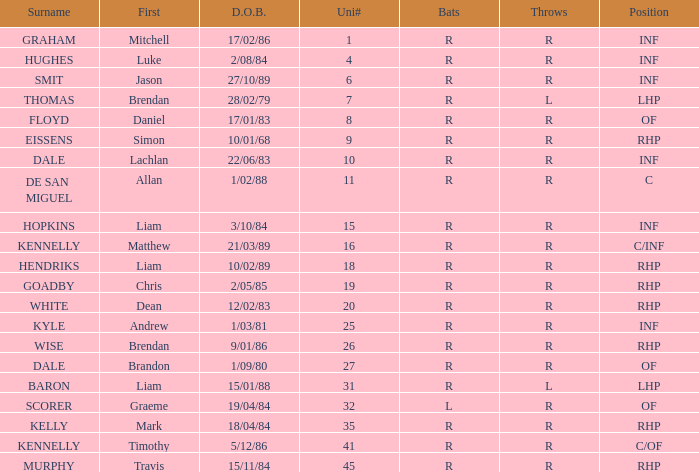Can you identify the batter whose last name is graham? R. 